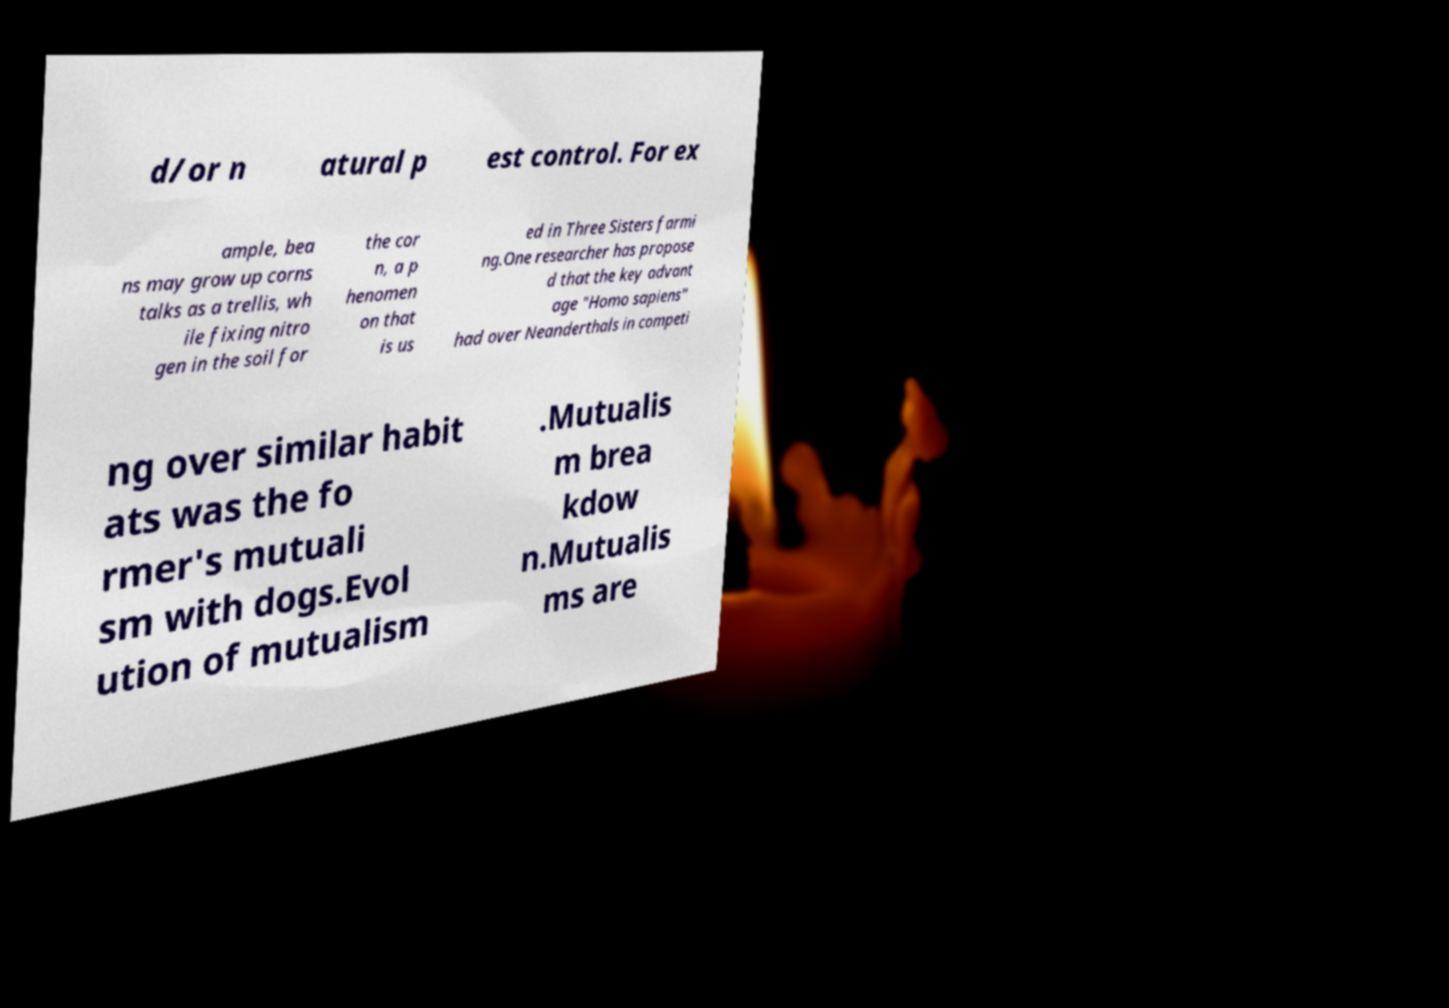Could you extract and type out the text from this image? d/or n atural p est control. For ex ample, bea ns may grow up corns talks as a trellis, wh ile fixing nitro gen in the soil for the cor n, a p henomen on that is us ed in Three Sisters farmi ng.One researcher has propose d that the key advant age "Homo sapiens" had over Neanderthals in competi ng over similar habit ats was the fo rmer's mutuali sm with dogs.Evol ution of mutualism .Mutualis m brea kdow n.Mutualis ms are 